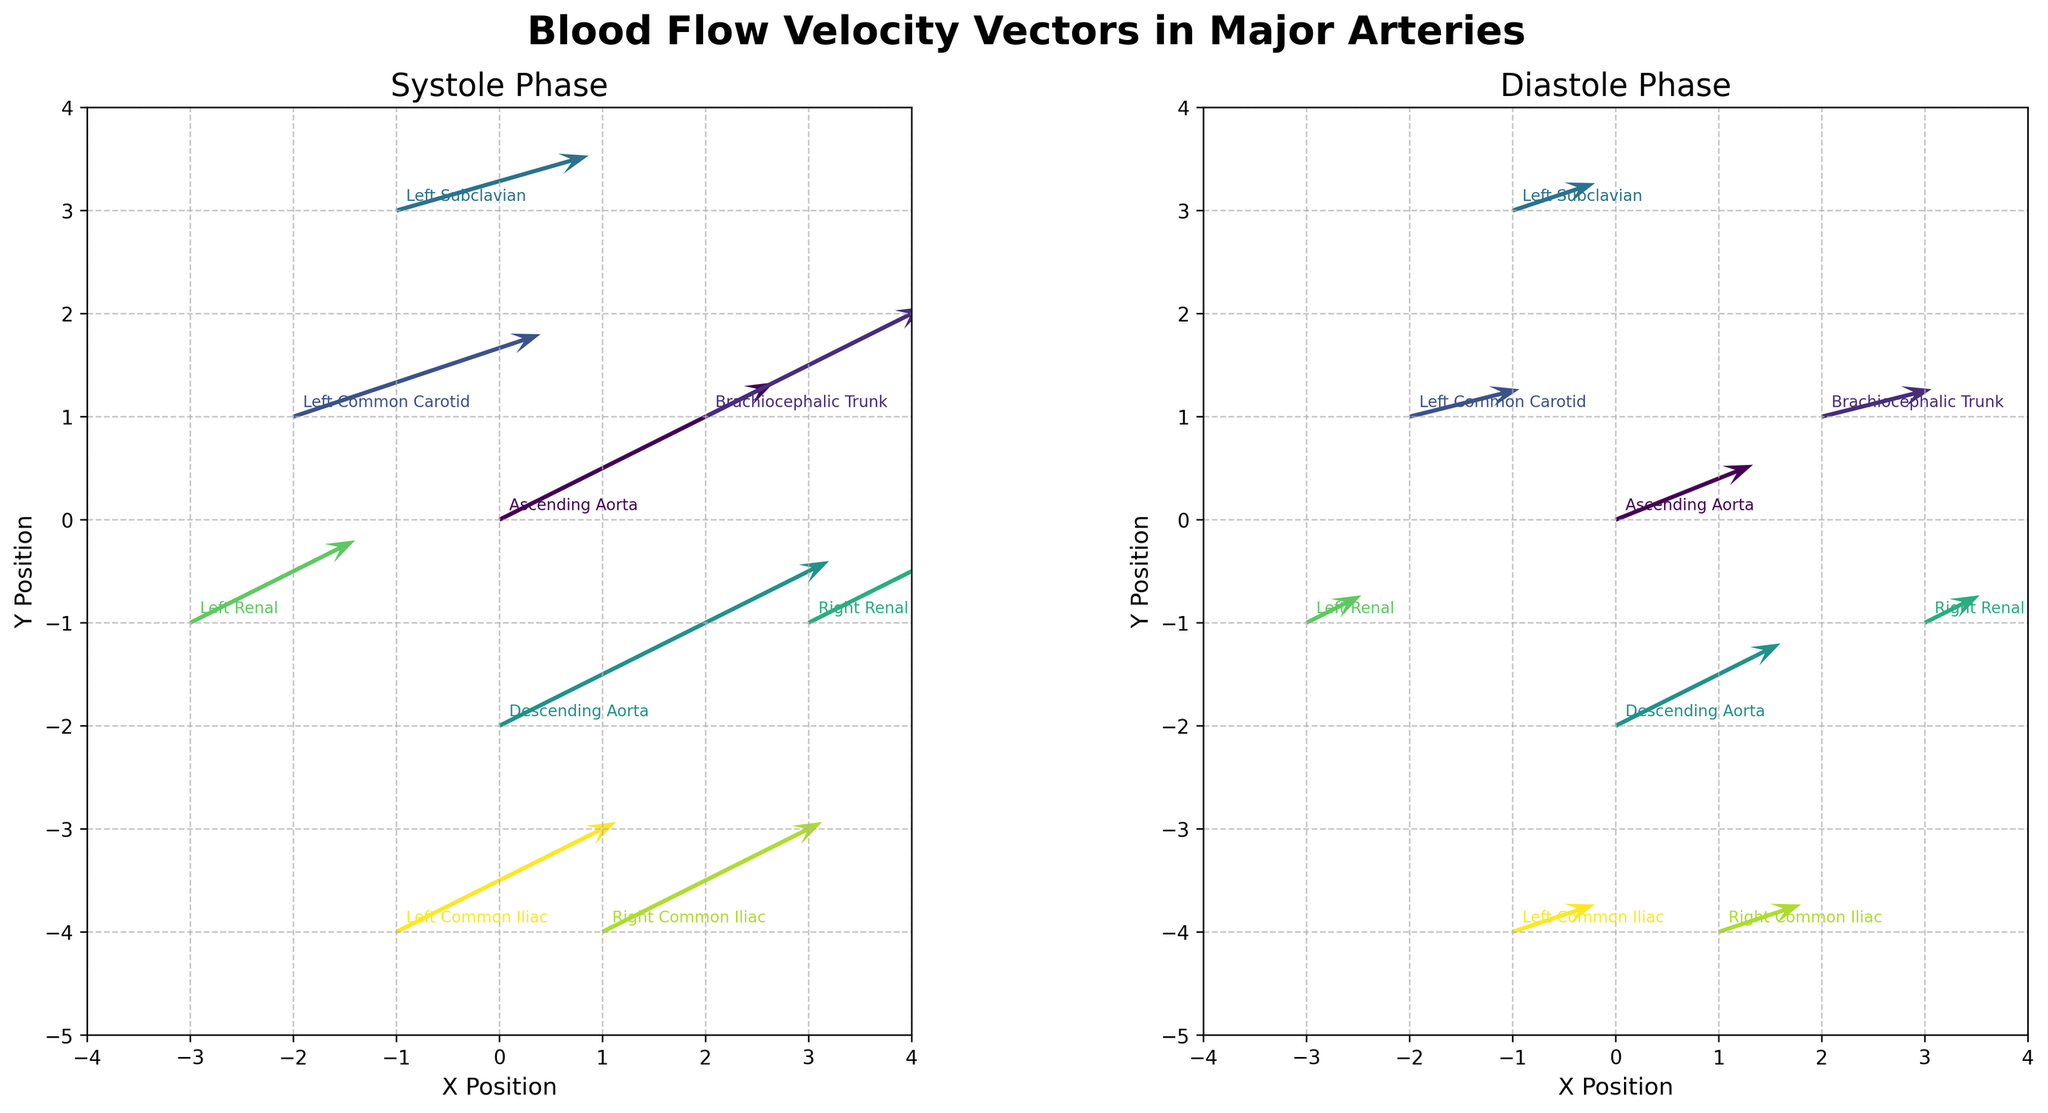What is the title of the figure? The title of the figure is often located at the top and is meant to give a summary of what the plot is about. In the given code, the title is set in the `fig.suptitle` function.
Answer: Blood Flow Velocity Vectors in Major Arteries What phases of the cardiac cycle are illustrated in the subplots? The code generates two subplots, each illustrating a different phase of the cardiac cycle. These phases are labeled in the code where it sets the subplot titles.
Answer: Systole and Diastole Which artery exhibits the highest blood flow velocity vector in both phases? To answer this, we need to compare the velocity vectors in both phases. The highest velocities are found by checking the plotted arrows' magnitudes or looking at the given data.
Answer: Ascending Aorta Are the blood flow velocities generally higher during systole or diastole? By looking at the length and magnitude of the arrows in both subplots, one can observe that the systole phase generally has longer arrows representing higher velocities than the diastole phase.
Answer: Systole How are the Renal arteries represented in terms of direction during systole? Examining the systole subplot, we can look at the direction of the arrows for the Right and Left Renal arteries to determine their orientation and direction. Both have arrows pointing generally downward, indicating the blood flow direction.
Answer: Downward What is the average horizontal velocity component (u) of the blood flow in the Left Common Iliac artery across both phases? To compute this average, sum the `u` values for the Left Common Iliac in both phases and then divide by 2. The u-values are 8 (Systole) and 3 (Diastole). Thus, the average is (8+3)/2.
Answer: 5.5 In which phase does the Right Renal artery have the lowest vertical velocity component (v)? Compare the `v` values for the Right Renal artery across both phases. In Systole, v=3 while in Diastole, v=1. Identify the lower value's corresponding phase.
Answer: Diastole What is the difference in the vertical velocity component (v) for the Descending Aorta between Systole and Diastole? Calculate the difference by subtracting the `v` value in Diastole from the `v` value in Systole. For the Descending Aorta, these values are 6 and 3 respectively, so the difference is 6 - 3.
Answer: 3 